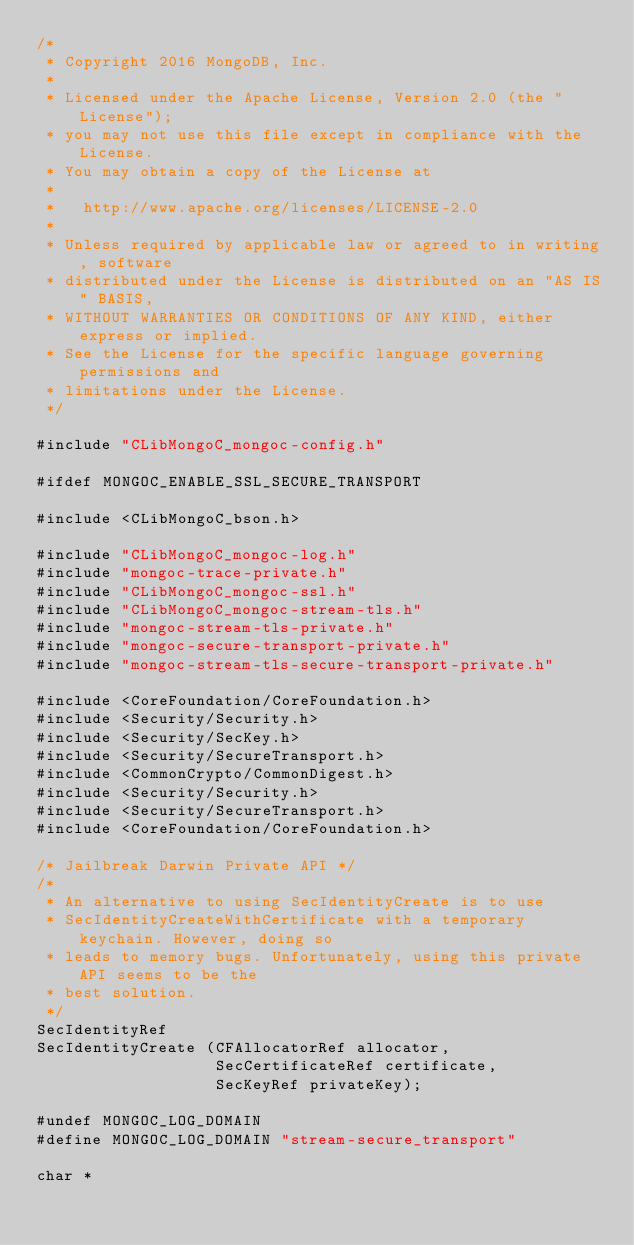<code> <loc_0><loc_0><loc_500><loc_500><_C_>/*
 * Copyright 2016 MongoDB, Inc.
 *
 * Licensed under the Apache License, Version 2.0 (the "License");
 * you may not use this file except in compliance with the License.
 * You may obtain a copy of the License at
 *
 *   http://www.apache.org/licenses/LICENSE-2.0
 *
 * Unless required by applicable law or agreed to in writing, software
 * distributed under the License is distributed on an "AS IS" BASIS,
 * WITHOUT WARRANTIES OR CONDITIONS OF ANY KIND, either express or implied.
 * See the License for the specific language governing permissions and
 * limitations under the License.
 */

#include "CLibMongoC_mongoc-config.h"

#ifdef MONGOC_ENABLE_SSL_SECURE_TRANSPORT

#include <CLibMongoC_bson.h>

#include "CLibMongoC_mongoc-log.h"
#include "mongoc-trace-private.h"
#include "CLibMongoC_mongoc-ssl.h"
#include "CLibMongoC_mongoc-stream-tls.h"
#include "mongoc-stream-tls-private.h"
#include "mongoc-secure-transport-private.h"
#include "mongoc-stream-tls-secure-transport-private.h"

#include <CoreFoundation/CoreFoundation.h>
#include <Security/Security.h>
#include <Security/SecKey.h>
#include <Security/SecureTransport.h>
#include <CommonCrypto/CommonDigest.h>
#include <Security/Security.h>
#include <Security/SecureTransport.h>
#include <CoreFoundation/CoreFoundation.h>

/* Jailbreak Darwin Private API */
/*
 * An alternative to using SecIdentityCreate is to use
 * SecIdentityCreateWithCertificate with a temporary keychain. However, doing so
 * leads to memory bugs. Unfortunately, using this private API seems to be the
 * best solution.
 */
SecIdentityRef
SecIdentityCreate (CFAllocatorRef allocator,
                   SecCertificateRef certificate,
                   SecKeyRef privateKey);

#undef MONGOC_LOG_DOMAIN
#define MONGOC_LOG_DOMAIN "stream-secure_transport"

char *</code> 